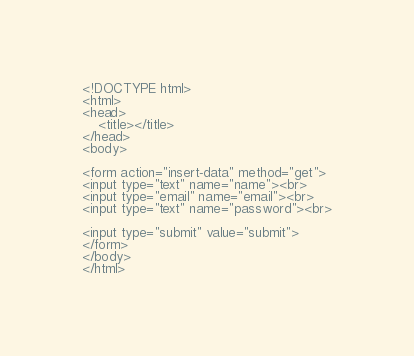<code> <loc_0><loc_0><loc_500><loc_500><_PHP_><!DOCTYPE html>
<html>
<head>
    <title></title>
</head>
<body>

<form action="insert-data" method="get">
<input type="text" name="name"><br>
<input type="email" name="email"><br>
<input type="text" name="password"><br>

<input type="submit" value="submit">
</form>
</body>
</html>
</code> 